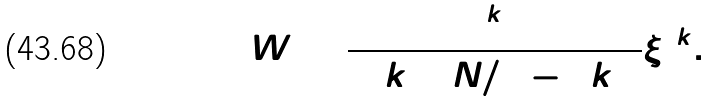<formula> <loc_0><loc_0><loc_500><loc_500>W = \frac { 2 ^ { 2 k + 1 } } { ( 4 k ) ! ( N / 2 - 2 k ) ! } \xi ^ { 4 k } .</formula> 